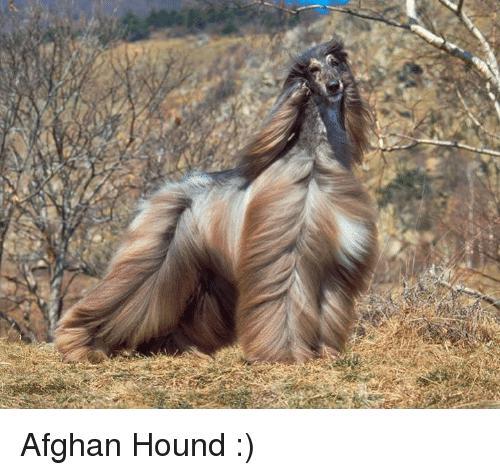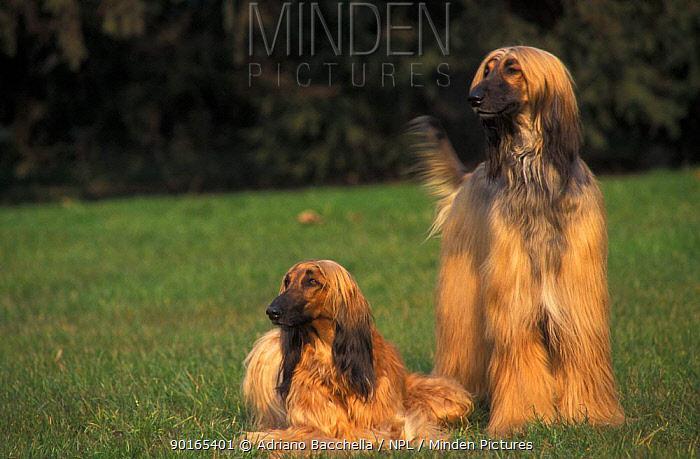The first image is the image on the left, the second image is the image on the right. Considering the images on both sides, is "A total of three afghan hounds are shown, including one hound that stands alone in an image and gazes toward the camera, and a reclining hound that is on the left of another dog in the other image." valid? Answer yes or no. Yes. The first image is the image on the left, the second image is the image on the right. For the images displayed, is the sentence "There are 3 dogs." factually correct? Answer yes or no. Yes. 